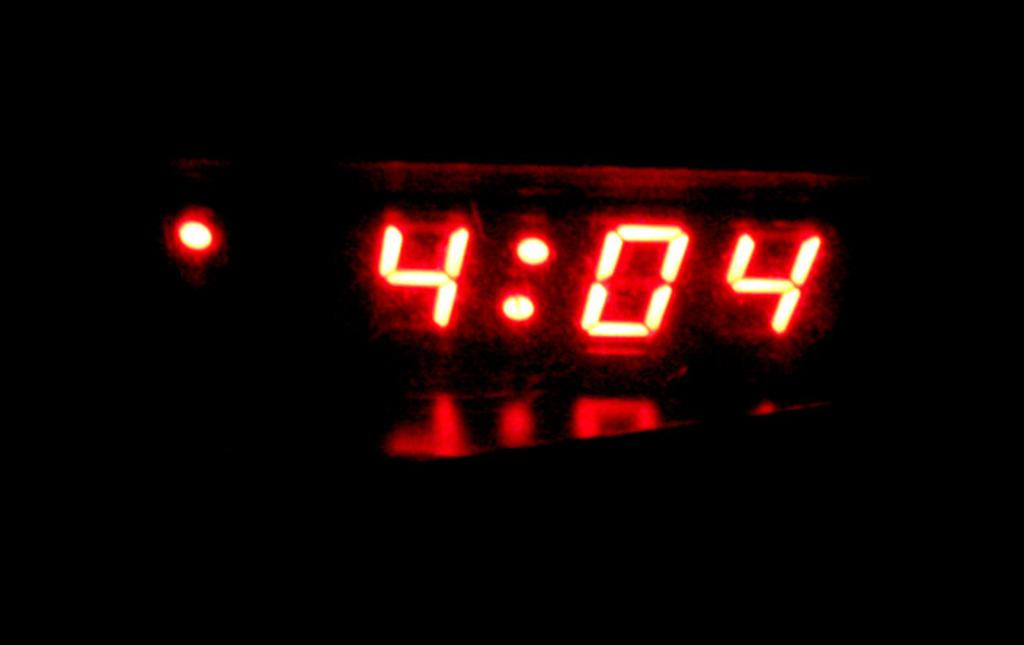<image>
Render a clear and concise summary of the photo. The time on the digital clock reads 4:04. 